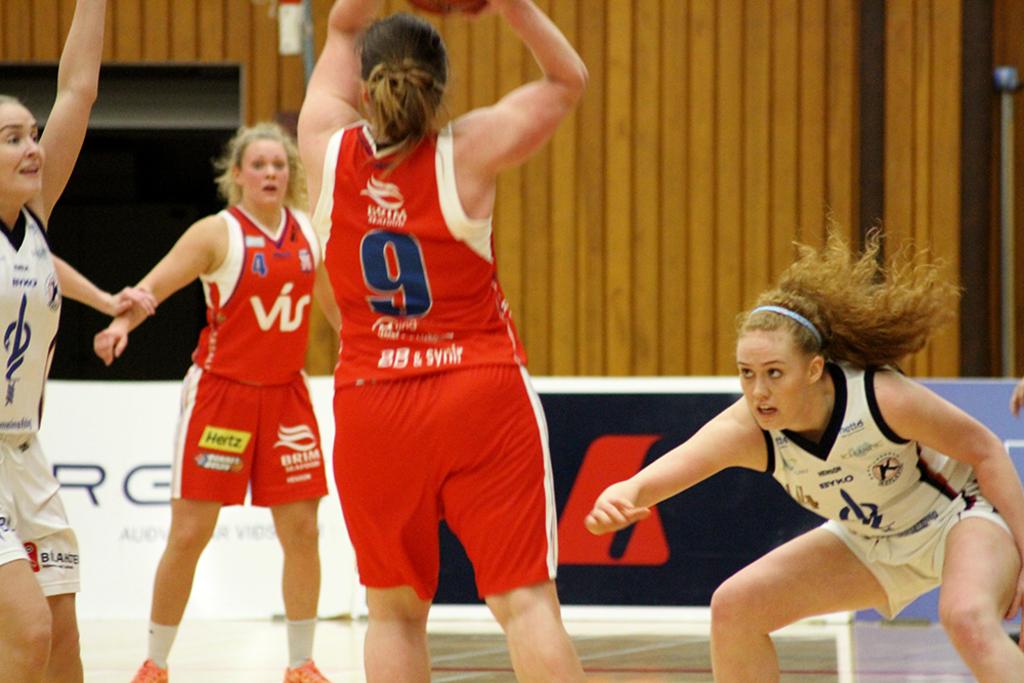What number is on the girls shirt with the ball?
Offer a terse response. 9. 